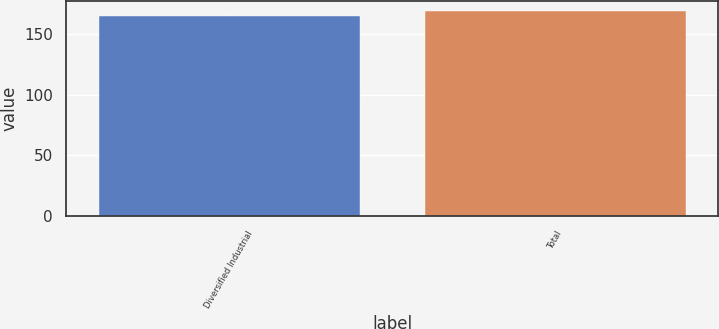Convert chart to OTSL. <chart><loc_0><loc_0><loc_500><loc_500><bar_chart><fcel>Diversified Industrial<fcel>Total<nl><fcel>165<fcel>169<nl></chart> 